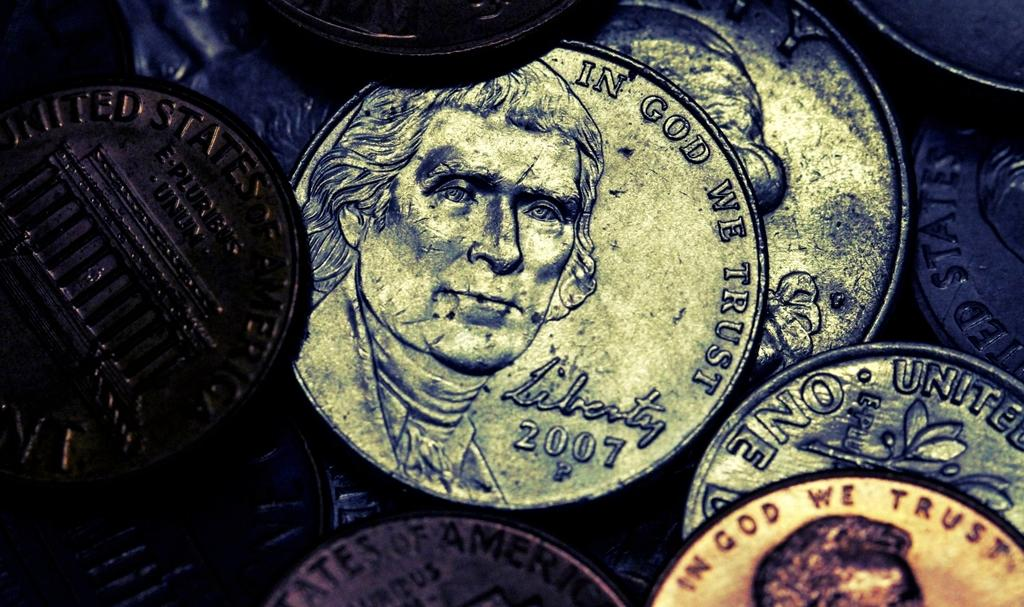<image>
Provide a brief description of the given image. A 2007 Liberty nickel on top of a pile of coins. 